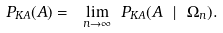Convert formula to latex. <formula><loc_0><loc_0><loc_500><loc_500>P _ { K A } ( A ) = \ \underset { n \rightarrow \infty } { \lim } \ P _ { K A } ( A \ | \ \Omega _ { n } ) .</formula> 